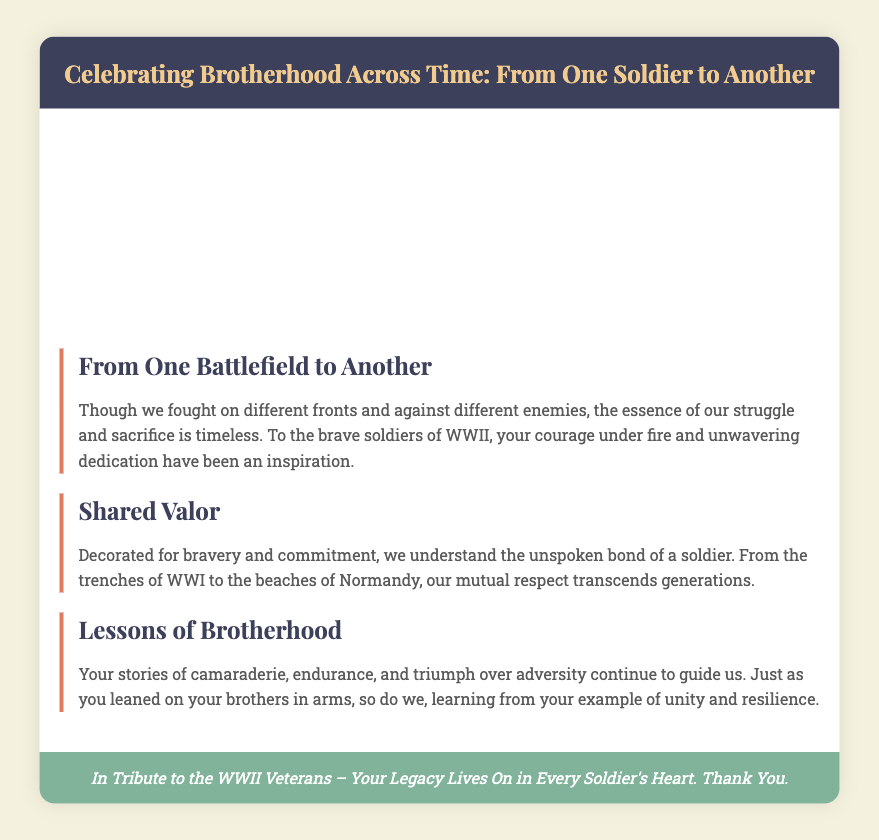what is the title of the card? The title is prominently displayed in the card header section, which reads "Celebrating Brotherhood Across Time: From One Soldier to Another."
Answer: Celebrating Brotherhood Across Time: From One Soldier to Another how many images are there in the split design? The split design consists of two images representing different wars, visually placed side by side.
Answer: two what is the theme of the first tribute? The first tribute discusses the essence of struggle and sacrifice by comparing different battlefields and highlighting the inspiration from WWII soldiers.
Answer: From One Battlefield to Another who are the subjects of the card's tributes? The card pays tribute specifically to WWII veterans for their courage and dedication, acknowledging their contributions.
Answer: WWII veterans what color is the footer background? The footer has a distinct color that stands out and is specifically noted in the design as #81b29a.
Answer: #81b29a how does the second tribute emphasize mutual respect? The second tribute reflects on a shared understanding of bravery and commitment, illustrating brotherhood across generations of soldiers.
Answer: Shared Valor what is the main message conveyed in the footer? The footer conveys gratitude and recognition for the legacy of WWII veterans, emphasizing their enduring impact on soldiers.
Answer: Your Legacy Lives On in Every Soldier's Heart what is the font used for the card's header? The card utilizes a specific font family for the header section, enhancing its visual appeal, which is noted as 'Playfair Display'.
Answer: Playfair Display 